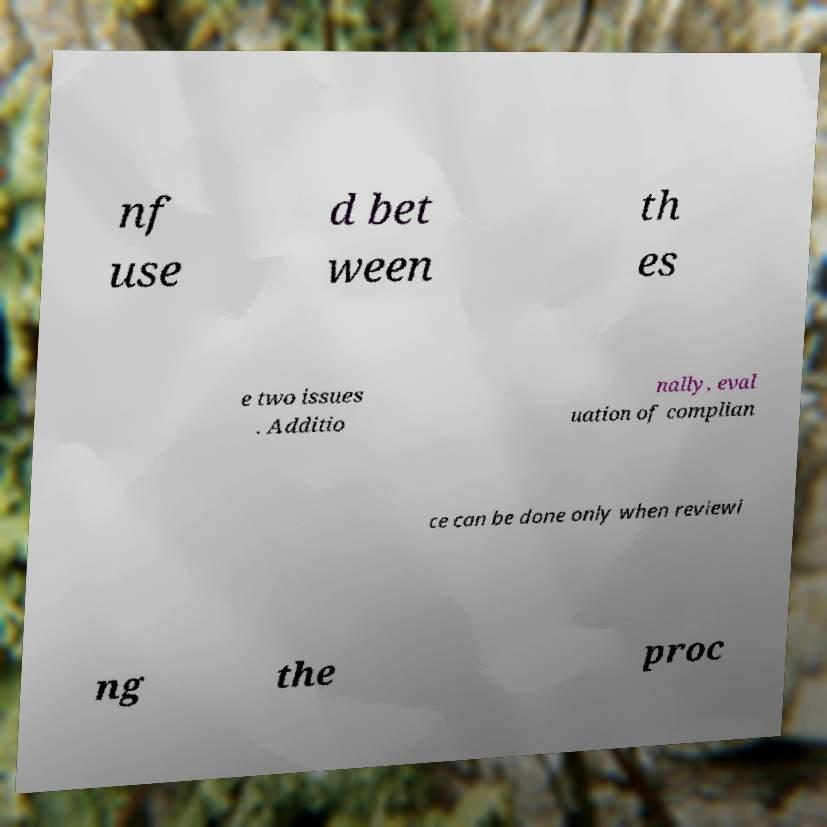Please read and relay the text visible in this image. What does it say? nf use d bet ween th es e two issues . Additio nally, eval uation of complian ce can be done only when reviewi ng the proc 